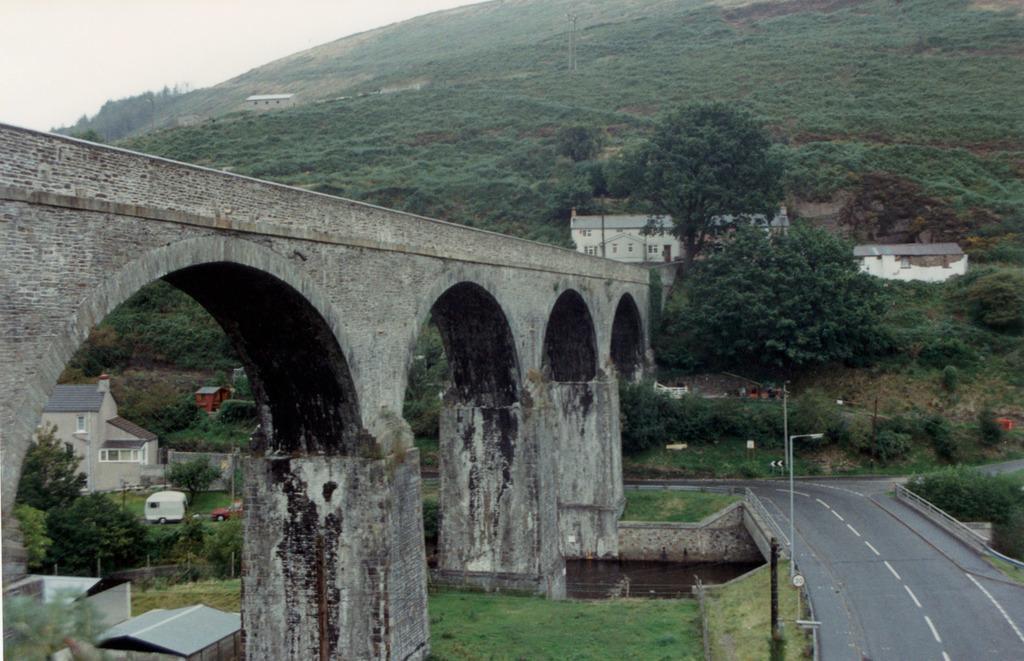Could you give a brief overview of what you see in this image? In this image, we can see some trees and roof houses. There is bridge and hill in the middle of the image. There is a road and pole in the bottom right of the image. There is a canal at the bottom of the image. There is a sky in the top left of the image. 